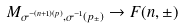<formula> <loc_0><loc_0><loc_500><loc_500>M _ { \sigma ^ { - ( n + 1 ) ( p ) } , \sigma ^ { - 1 } ( p _ { \pm } ) } \to F ( n , \pm )</formula> 